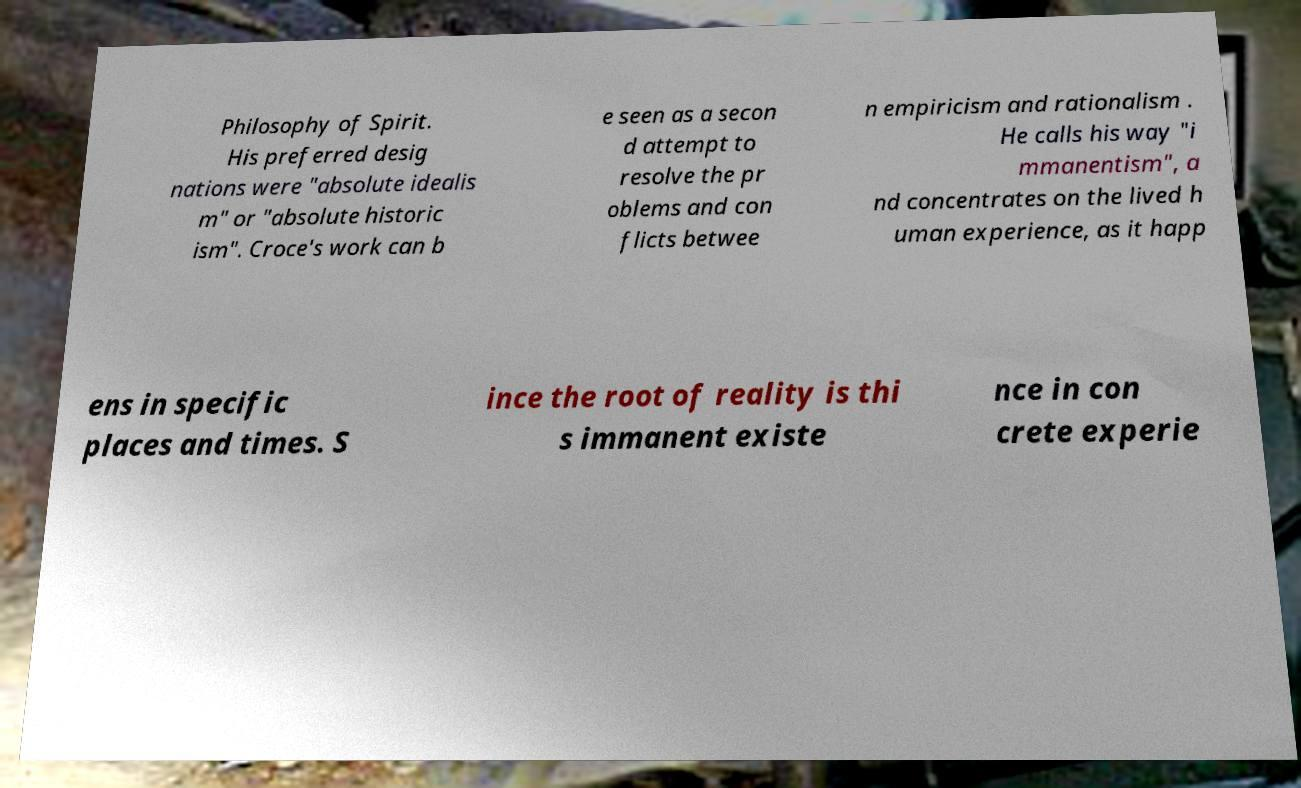Can you read and provide the text displayed in the image?This photo seems to have some interesting text. Can you extract and type it out for me? Philosophy of Spirit. His preferred desig nations were "absolute idealis m" or "absolute historic ism". Croce's work can b e seen as a secon d attempt to resolve the pr oblems and con flicts betwee n empiricism and rationalism . He calls his way "i mmanentism", a nd concentrates on the lived h uman experience, as it happ ens in specific places and times. S ince the root of reality is thi s immanent existe nce in con crete experie 